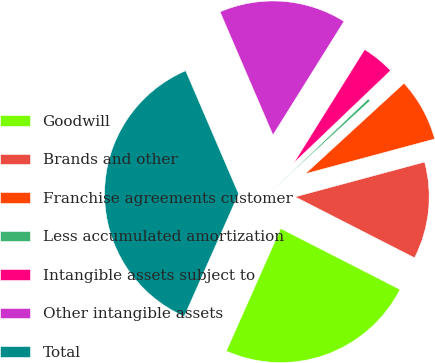<chart> <loc_0><loc_0><loc_500><loc_500><pie_chart><fcel>Goodwill<fcel>Brands and other<fcel>Franchise agreements customer<fcel>Less accumulated amortization<fcel>Intangible assets subject to<fcel>Other intangible assets<fcel>Total<nl><fcel>24.13%<fcel>11.7%<fcel>7.63%<fcel>0.32%<fcel>3.98%<fcel>15.35%<fcel>36.9%<nl></chart> 